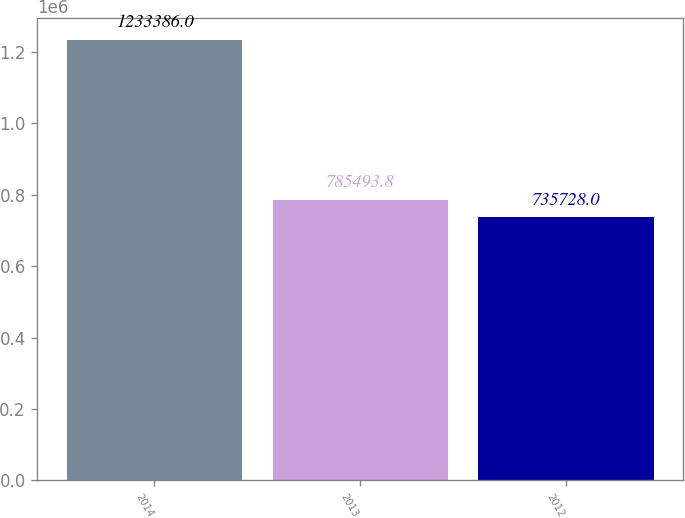Convert chart to OTSL. <chart><loc_0><loc_0><loc_500><loc_500><bar_chart><fcel>2014<fcel>2013<fcel>2012<nl><fcel>1.23339e+06<fcel>785494<fcel>735728<nl></chart> 